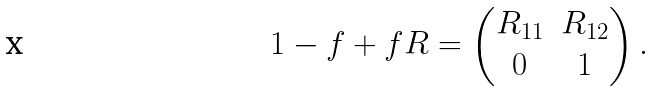<formula> <loc_0><loc_0><loc_500><loc_500>1 - f + f R = \begin{pmatrix} R _ { 1 1 } & R _ { 1 2 } \\ 0 & 1 \end{pmatrix} .</formula> 